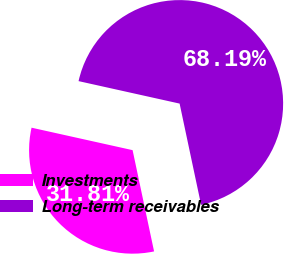Convert chart to OTSL. <chart><loc_0><loc_0><loc_500><loc_500><pie_chart><fcel>Investments<fcel>Long-term receivables<nl><fcel>31.81%<fcel>68.19%<nl></chart> 